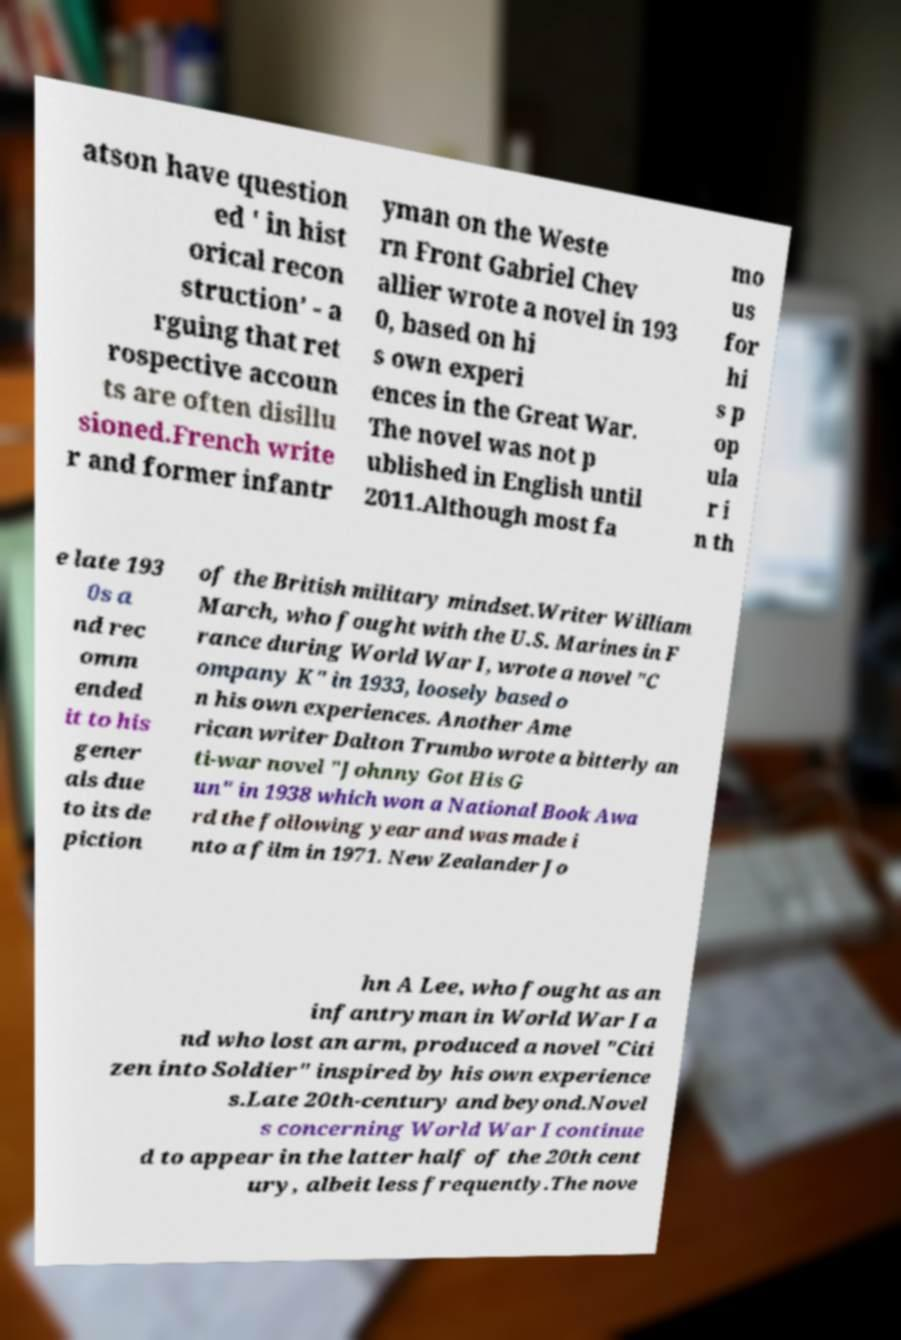I need the written content from this picture converted into text. Can you do that? atson have question ed ' in hist orical recon struction’ - a rguing that ret rospective accoun ts are often disillu sioned.French write r and former infantr yman on the Weste rn Front Gabriel Chev allier wrote a novel in 193 0, based on hi s own experi ences in the Great War. The novel was not p ublished in English until 2011.Although most fa mo us for hi s p op ula r i n th e late 193 0s a nd rec omm ended it to his gener als due to its de piction of the British military mindset.Writer William March, who fought with the U.S. Marines in F rance during World War I, wrote a novel "C ompany K" in 1933, loosely based o n his own experiences. Another Ame rican writer Dalton Trumbo wrote a bitterly an ti-war novel "Johnny Got His G un" in 1938 which won a National Book Awa rd the following year and was made i nto a film in 1971. New Zealander Jo hn A Lee, who fought as an infantryman in World War I a nd who lost an arm, produced a novel "Citi zen into Soldier" inspired by his own experience s.Late 20th-century and beyond.Novel s concerning World War I continue d to appear in the latter half of the 20th cent ury, albeit less frequently.The nove 